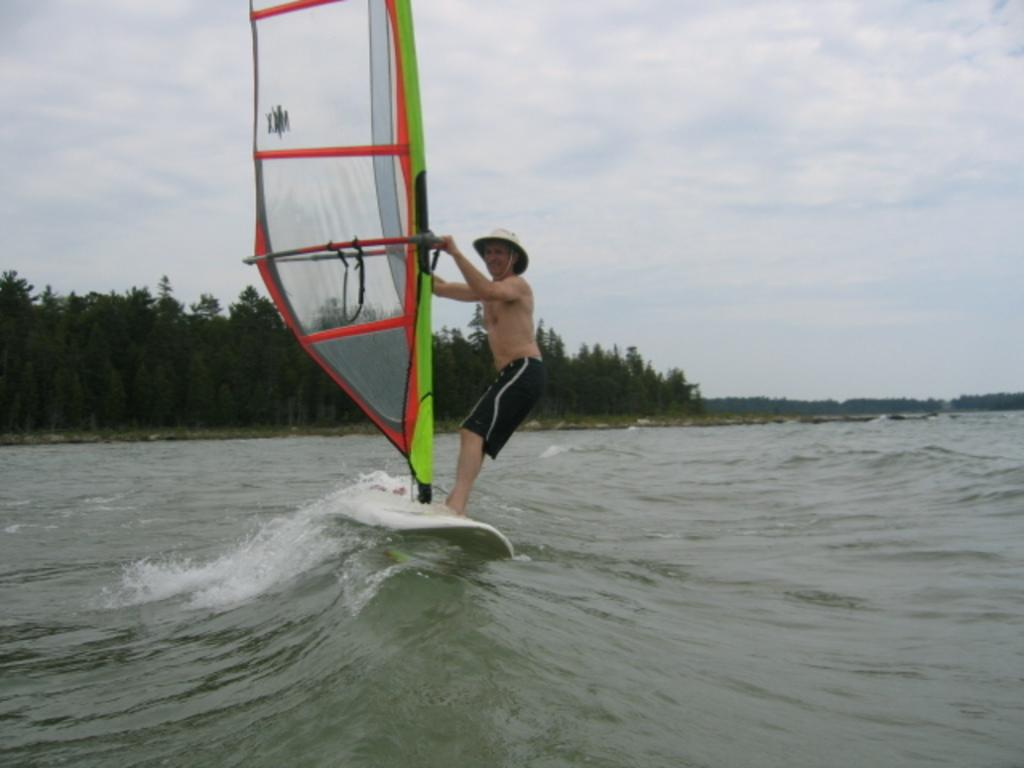What is the main subject of the image? There is a person in the image. What is the person doing in the image? The person is writing a ship. What can be seen in the foreground of the image? There is water visible in the image. What is visible in the background of the image? There are trees and the sky visible in the background of the image. What type of spark can be seen coming from the person's boot in the image? There is no spark or boot present in the image; the person is writing a ship. 